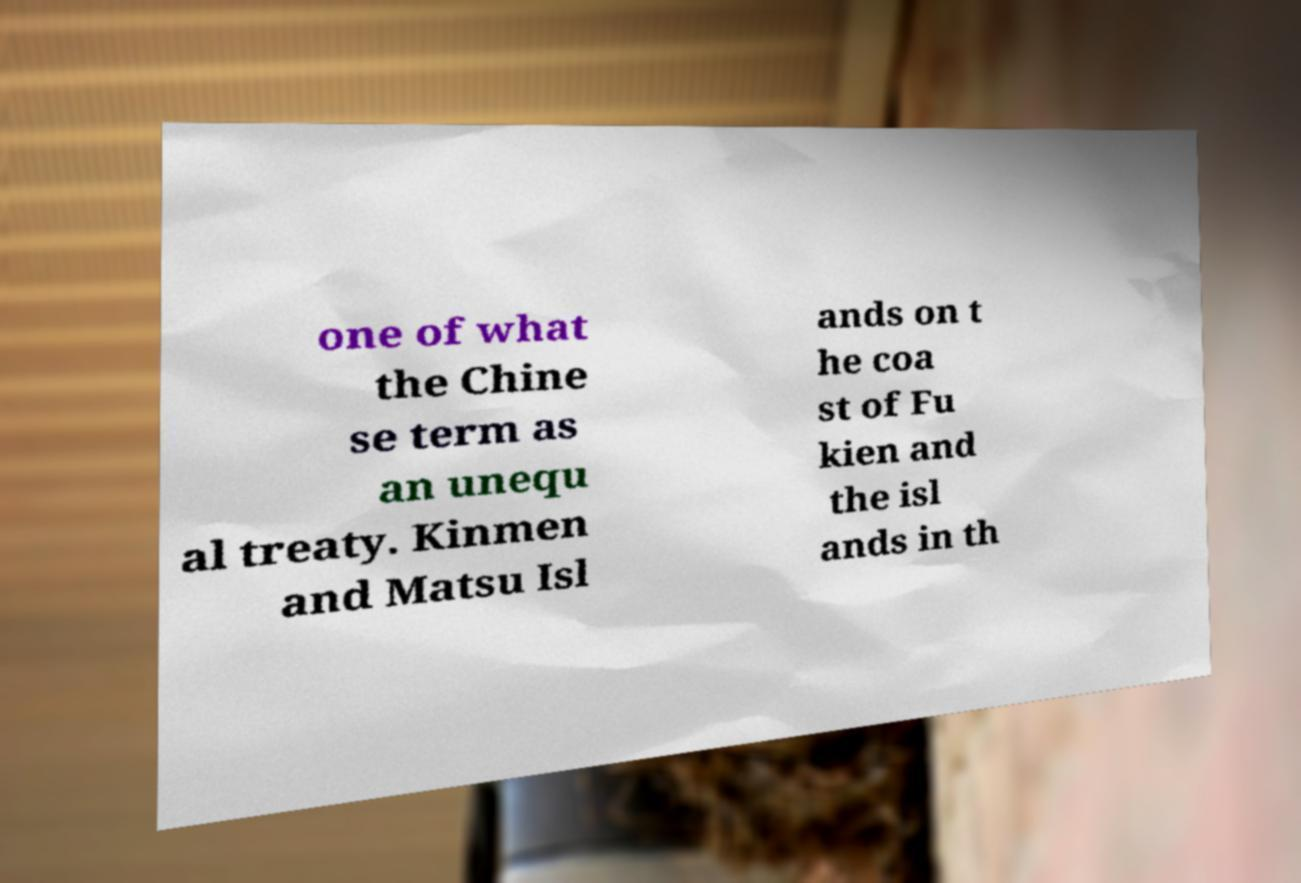Can you read and provide the text displayed in the image?This photo seems to have some interesting text. Can you extract and type it out for me? one of what the Chine se term as an unequ al treaty. Kinmen and Matsu Isl ands on t he coa st of Fu kien and the isl ands in th 